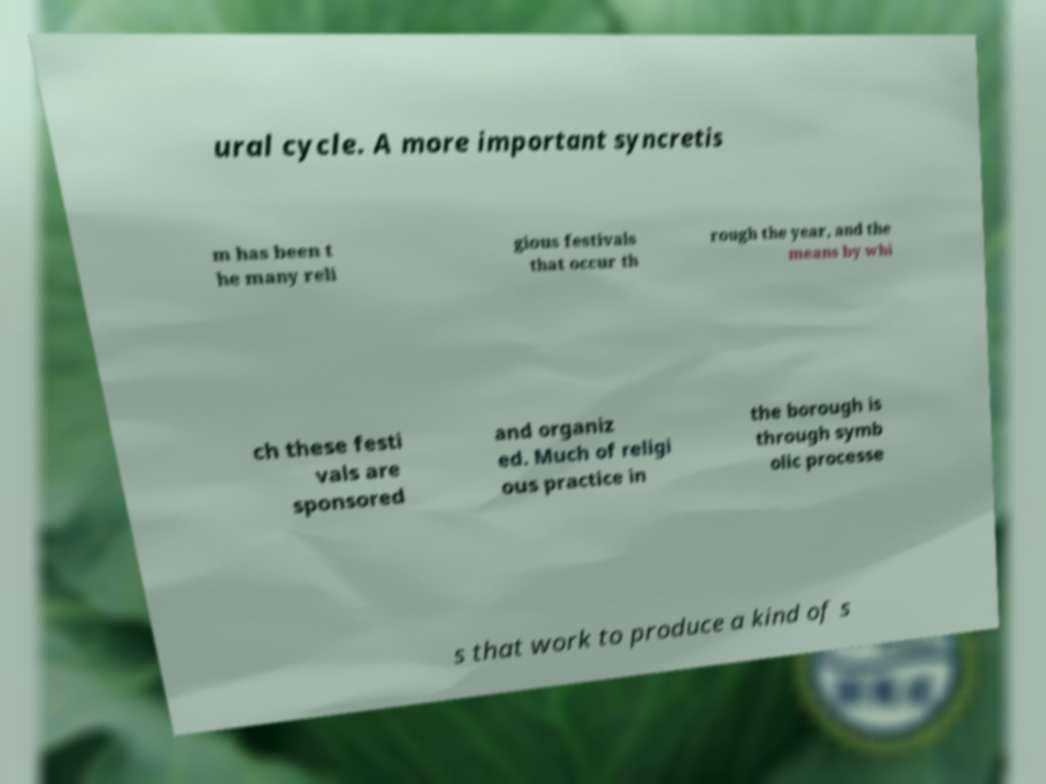I need the written content from this picture converted into text. Can you do that? ural cycle. A more important syncretis m has been t he many reli gious festivals that occur th rough the year, and the means by whi ch these festi vals are sponsored and organiz ed. Much of religi ous practice in the borough is through symb olic processe s that work to produce a kind of s 